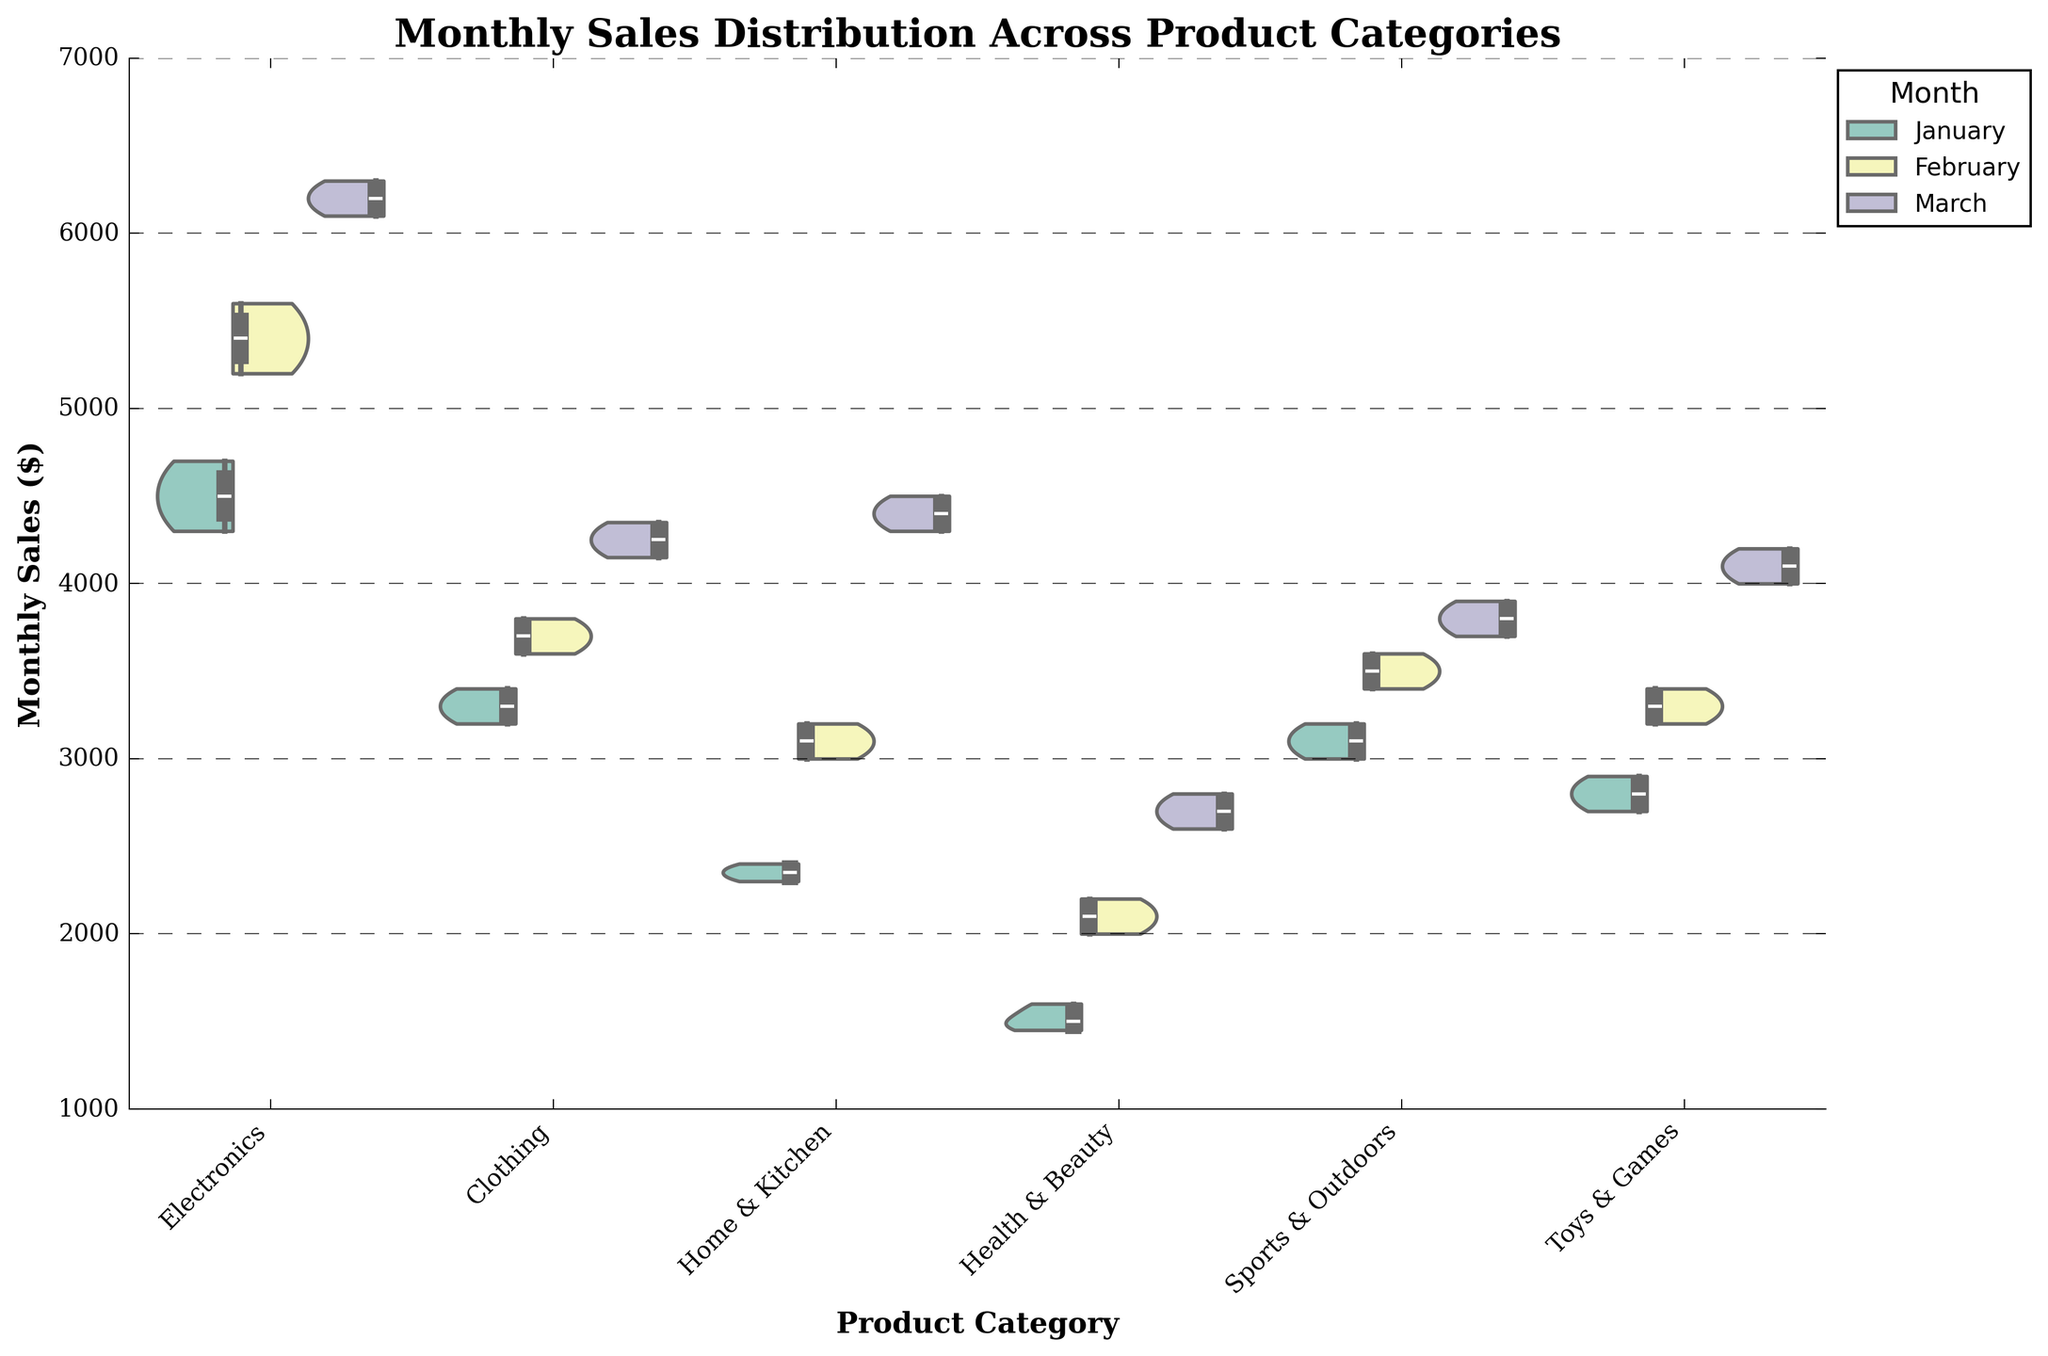What is the title of the figure? The title of the figure is located at the top and it summarizes the purpose of the plot. It reads 'Monthly Sales Distribution Across Product Categories'.
Answer: Monthly Sales Distribution Across Product Categories How are the differences in monthly sales values represented for each category? The differences in sales values are shown using the violin plot shapes, which display the distribution's density, and the box plot overlay, which provides summary statistics like median, quartiles, and whiskers.
Answer: Violin plots with box plot overlays Which product category had the highest median sales in March? To determine the median sales, locate the middle of the box in the box plot overlay within each violin plot for March. Compare these medians across categories to identify the highest one. Electronics has the visibly highest median.
Answer: Electronics How does the distribution of monthly sales for "Home & Kitchen" in January compare to February? Look at the width and size of the violin plots for "Home & Kitchen" for January and February. January has a smaller and lower distribution compared to February, indicating fewer and lower sales.
Answer: Lower and smaller in January than February Which product category shows the most consistent monthly sales distribution across all months? Consistency can be understood by looking at categories with narrow violin plots and narrow interquartile ranges throughout all months. "Health & Beauty" has more consistent distributions as indicated by the relatively narrow violins and boxes.
Answer: Health & Beauty What is the interquartile range (IQR) of "Sports & Outdoors" in March? The IQR is calculated by subtracting the lower quartile (bottom edge of the box) from the upper quartile (top edge of the box) on the box plot for "Sports & Outdoors" in March. The quartiles are 3700 and 3900. Therefore, IQR = 3900 - 3700 = 200.
Answer: 200 Which product category's distribution shows the widest spread in March? The widest spread is observed by identifying the violin plot with the largest vertical span, including the whiskers in March. "Electronics" has the widest spread indicating the highest variability in sales.
Answer: Electronics Provide the median monthly sales for "Clothing" in February. Identify the median line in the box plot overlay for the "Clothing" category in February. The median line in this box plot shows the median value, which is around 3700.
Answer: 3700 What's the main difference in the sales distribution between "Toys & Games" and "Health & Beauty" in January? Compare the shapes of the violin plots of both categories in January. "Toys & Games" has a wider and potentially higher distribution, indicating more variability and higher sales compared to the narrow, low range of "Health & Beauty".
Answer: Higher and wider in "Toys & Games" Which product category had its lowest median sales in January? Compare the medians indicated by the solid line in the center of the box of each category's violin plot for January. "Health & Beauty" has the lowest median.
Answer: Health & Beauty 